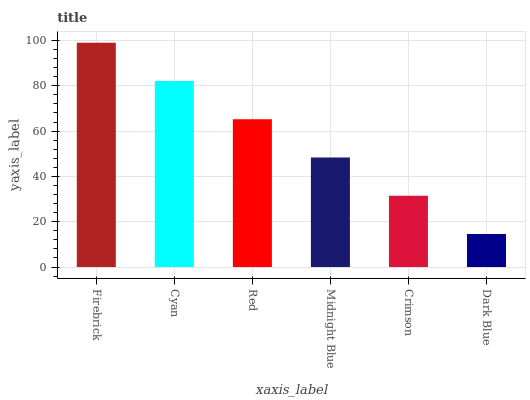Is Dark Blue the minimum?
Answer yes or no. Yes. Is Firebrick the maximum?
Answer yes or no. Yes. Is Cyan the minimum?
Answer yes or no. No. Is Cyan the maximum?
Answer yes or no. No. Is Firebrick greater than Cyan?
Answer yes or no. Yes. Is Cyan less than Firebrick?
Answer yes or no. Yes. Is Cyan greater than Firebrick?
Answer yes or no. No. Is Firebrick less than Cyan?
Answer yes or no. No. Is Red the high median?
Answer yes or no. Yes. Is Midnight Blue the low median?
Answer yes or no. Yes. Is Dark Blue the high median?
Answer yes or no. No. Is Firebrick the low median?
Answer yes or no. No. 